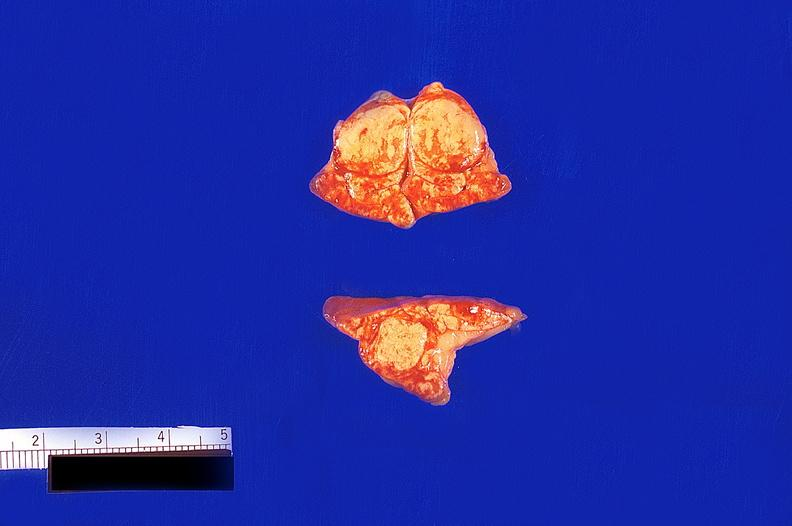what is present?
Answer the question using a single word or phrase. Endocrine 